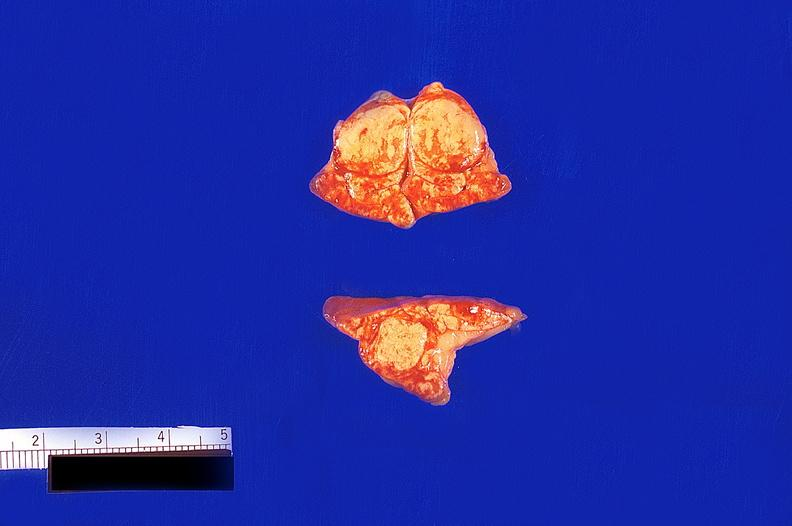what is present?
Answer the question using a single word or phrase. Endocrine 